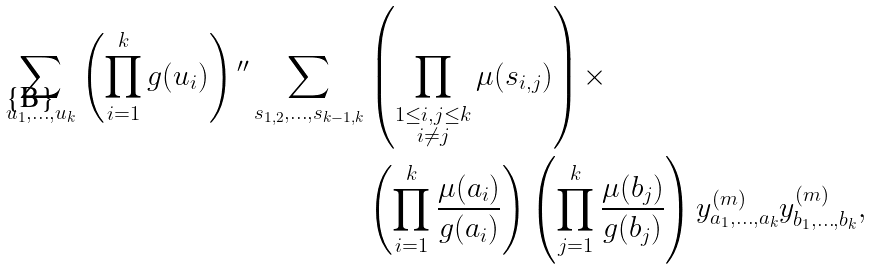Convert formula to latex. <formula><loc_0><loc_0><loc_500><loc_500>\sum _ { u _ { 1 } , \dots , u _ { k } } \left ( \prod _ { i = 1 } ^ { k } g ( u _ { i } ) \right ) { ^ { \prime \prime } } \sum _ { s _ { 1 , 2 } , \dots , s _ { k - 1 , k } } & \left ( \prod _ { \substack { 1 \leq i , j \leq k \\ i \neq j } } \mu ( s _ { i , j } ) \right ) \times \\ & \left ( \prod _ { i = 1 } ^ { k } \frac { \mu ( a _ { i } ) } { g ( a _ { i } ) } \right ) \left ( \prod _ { j = 1 } ^ { k } \frac { \mu ( b _ { j } ) } { g ( b _ { j } ) } \right ) y ^ { ( m ) } _ { a _ { 1 } , \dots , a _ { k } } y ^ { ( m ) } _ { b _ { 1 } , \dots , b _ { k } } ,</formula> 